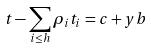<formula> <loc_0><loc_0><loc_500><loc_500>t - \sum _ { i \leq h } \rho _ { i } t _ { i } = c + y b</formula> 